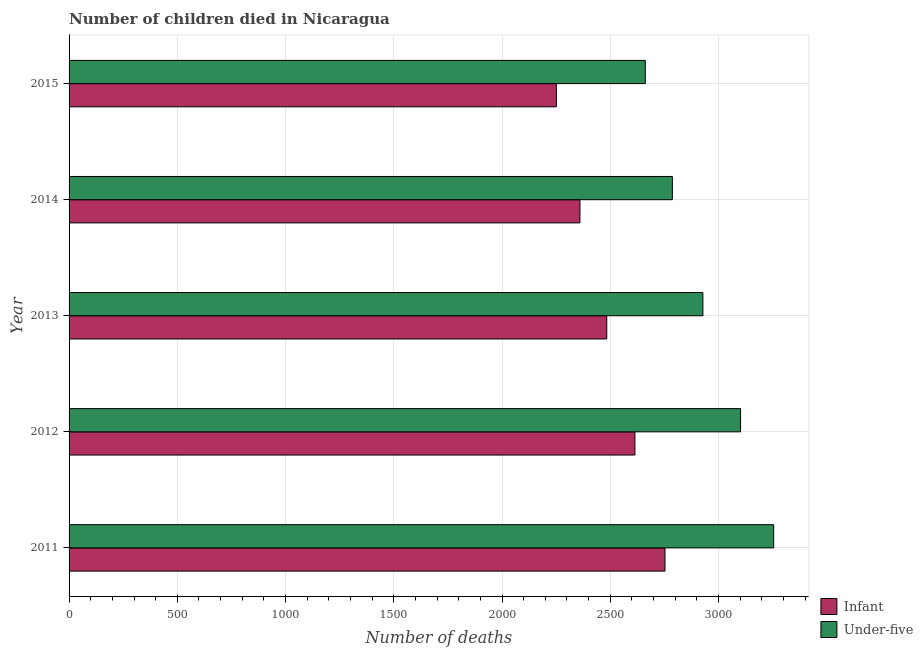How many different coloured bars are there?
Give a very brief answer. 2. How many groups of bars are there?
Ensure brevity in your answer.  5. What is the label of the 2nd group of bars from the top?
Provide a succinct answer. 2014. What is the number of infant deaths in 2015?
Make the answer very short. 2251. Across all years, what is the maximum number of under-five deaths?
Offer a very short reply. 3255. Across all years, what is the minimum number of under-five deaths?
Offer a very short reply. 2662. In which year was the number of infant deaths minimum?
Keep it short and to the point. 2015. What is the total number of under-five deaths in the graph?
Offer a terse response. 1.47e+04. What is the difference between the number of infant deaths in 2013 and that in 2014?
Your answer should be compact. 124. What is the difference between the number of infant deaths in 2014 and the number of under-five deaths in 2012?
Offer a very short reply. -742. What is the average number of under-five deaths per year?
Your response must be concise. 2946.8. In the year 2011, what is the difference between the number of under-five deaths and number of infant deaths?
Your answer should be very brief. 502. In how many years, is the number of infant deaths greater than 1100 ?
Offer a very short reply. 5. What is the ratio of the number of under-five deaths in 2013 to that in 2014?
Offer a terse response. 1.05. Is the difference between the number of infant deaths in 2013 and 2015 greater than the difference between the number of under-five deaths in 2013 and 2015?
Provide a succinct answer. No. What is the difference between the highest and the second highest number of under-five deaths?
Your answer should be compact. 153. What is the difference between the highest and the lowest number of infant deaths?
Offer a terse response. 502. In how many years, is the number of infant deaths greater than the average number of infant deaths taken over all years?
Offer a very short reply. 2. What does the 1st bar from the top in 2011 represents?
Provide a short and direct response. Under-five. What does the 2nd bar from the bottom in 2015 represents?
Give a very brief answer. Under-five. How many bars are there?
Make the answer very short. 10. Does the graph contain any zero values?
Provide a short and direct response. No. Does the graph contain grids?
Make the answer very short. Yes. How are the legend labels stacked?
Your answer should be very brief. Vertical. What is the title of the graph?
Your answer should be compact. Number of children died in Nicaragua. What is the label or title of the X-axis?
Make the answer very short. Number of deaths. What is the Number of deaths of Infant in 2011?
Ensure brevity in your answer.  2753. What is the Number of deaths of Under-five in 2011?
Your answer should be very brief. 3255. What is the Number of deaths in Infant in 2012?
Offer a very short reply. 2614. What is the Number of deaths in Under-five in 2012?
Your answer should be very brief. 3102. What is the Number of deaths of Infant in 2013?
Offer a terse response. 2484. What is the Number of deaths of Under-five in 2013?
Provide a succinct answer. 2928. What is the Number of deaths in Infant in 2014?
Your answer should be compact. 2360. What is the Number of deaths in Under-five in 2014?
Offer a very short reply. 2787. What is the Number of deaths in Infant in 2015?
Keep it short and to the point. 2251. What is the Number of deaths of Under-five in 2015?
Provide a short and direct response. 2662. Across all years, what is the maximum Number of deaths in Infant?
Your response must be concise. 2753. Across all years, what is the maximum Number of deaths in Under-five?
Your answer should be very brief. 3255. Across all years, what is the minimum Number of deaths of Infant?
Offer a very short reply. 2251. Across all years, what is the minimum Number of deaths of Under-five?
Your answer should be compact. 2662. What is the total Number of deaths of Infant in the graph?
Ensure brevity in your answer.  1.25e+04. What is the total Number of deaths of Under-five in the graph?
Your answer should be very brief. 1.47e+04. What is the difference between the Number of deaths in Infant in 2011 and that in 2012?
Provide a short and direct response. 139. What is the difference between the Number of deaths of Under-five in 2011 and that in 2012?
Make the answer very short. 153. What is the difference between the Number of deaths in Infant in 2011 and that in 2013?
Keep it short and to the point. 269. What is the difference between the Number of deaths in Under-five in 2011 and that in 2013?
Provide a succinct answer. 327. What is the difference between the Number of deaths of Infant in 2011 and that in 2014?
Provide a short and direct response. 393. What is the difference between the Number of deaths in Under-five in 2011 and that in 2014?
Offer a terse response. 468. What is the difference between the Number of deaths in Infant in 2011 and that in 2015?
Ensure brevity in your answer.  502. What is the difference between the Number of deaths of Under-five in 2011 and that in 2015?
Keep it short and to the point. 593. What is the difference between the Number of deaths of Infant in 2012 and that in 2013?
Your answer should be compact. 130. What is the difference between the Number of deaths of Under-five in 2012 and that in 2013?
Offer a very short reply. 174. What is the difference between the Number of deaths in Infant in 2012 and that in 2014?
Provide a succinct answer. 254. What is the difference between the Number of deaths in Under-five in 2012 and that in 2014?
Your response must be concise. 315. What is the difference between the Number of deaths in Infant in 2012 and that in 2015?
Your response must be concise. 363. What is the difference between the Number of deaths of Under-five in 2012 and that in 2015?
Ensure brevity in your answer.  440. What is the difference between the Number of deaths in Infant in 2013 and that in 2014?
Give a very brief answer. 124. What is the difference between the Number of deaths of Under-five in 2013 and that in 2014?
Keep it short and to the point. 141. What is the difference between the Number of deaths of Infant in 2013 and that in 2015?
Provide a succinct answer. 233. What is the difference between the Number of deaths in Under-five in 2013 and that in 2015?
Make the answer very short. 266. What is the difference between the Number of deaths of Infant in 2014 and that in 2015?
Offer a terse response. 109. What is the difference between the Number of deaths of Under-five in 2014 and that in 2015?
Keep it short and to the point. 125. What is the difference between the Number of deaths of Infant in 2011 and the Number of deaths of Under-five in 2012?
Offer a very short reply. -349. What is the difference between the Number of deaths of Infant in 2011 and the Number of deaths of Under-five in 2013?
Your answer should be very brief. -175. What is the difference between the Number of deaths in Infant in 2011 and the Number of deaths in Under-five in 2014?
Ensure brevity in your answer.  -34. What is the difference between the Number of deaths of Infant in 2011 and the Number of deaths of Under-five in 2015?
Offer a very short reply. 91. What is the difference between the Number of deaths of Infant in 2012 and the Number of deaths of Under-five in 2013?
Ensure brevity in your answer.  -314. What is the difference between the Number of deaths of Infant in 2012 and the Number of deaths of Under-five in 2014?
Offer a terse response. -173. What is the difference between the Number of deaths of Infant in 2012 and the Number of deaths of Under-five in 2015?
Offer a very short reply. -48. What is the difference between the Number of deaths in Infant in 2013 and the Number of deaths in Under-five in 2014?
Your response must be concise. -303. What is the difference between the Number of deaths of Infant in 2013 and the Number of deaths of Under-five in 2015?
Make the answer very short. -178. What is the difference between the Number of deaths in Infant in 2014 and the Number of deaths in Under-five in 2015?
Offer a very short reply. -302. What is the average Number of deaths of Infant per year?
Ensure brevity in your answer.  2492.4. What is the average Number of deaths of Under-five per year?
Your response must be concise. 2946.8. In the year 2011, what is the difference between the Number of deaths in Infant and Number of deaths in Under-five?
Keep it short and to the point. -502. In the year 2012, what is the difference between the Number of deaths in Infant and Number of deaths in Under-five?
Your response must be concise. -488. In the year 2013, what is the difference between the Number of deaths of Infant and Number of deaths of Under-five?
Your answer should be compact. -444. In the year 2014, what is the difference between the Number of deaths of Infant and Number of deaths of Under-five?
Your answer should be very brief. -427. In the year 2015, what is the difference between the Number of deaths in Infant and Number of deaths in Under-five?
Offer a terse response. -411. What is the ratio of the Number of deaths of Infant in 2011 to that in 2012?
Your answer should be compact. 1.05. What is the ratio of the Number of deaths of Under-five in 2011 to that in 2012?
Your response must be concise. 1.05. What is the ratio of the Number of deaths in Infant in 2011 to that in 2013?
Keep it short and to the point. 1.11. What is the ratio of the Number of deaths of Under-five in 2011 to that in 2013?
Offer a terse response. 1.11. What is the ratio of the Number of deaths of Infant in 2011 to that in 2014?
Provide a short and direct response. 1.17. What is the ratio of the Number of deaths in Under-five in 2011 to that in 2014?
Your answer should be very brief. 1.17. What is the ratio of the Number of deaths in Infant in 2011 to that in 2015?
Provide a succinct answer. 1.22. What is the ratio of the Number of deaths in Under-five in 2011 to that in 2015?
Provide a succinct answer. 1.22. What is the ratio of the Number of deaths in Infant in 2012 to that in 2013?
Make the answer very short. 1.05. What is the ratio of the Number of deaths of Under-five in 2012 to that in 2013?
Provide a short and direct response. 1.06. What is the ratio of the Number of deaths of Infant in 2012 to that in 2014?
Give a very brief answer. 1.11. What is the ratio of the Number of deaths of Under-five in 2012 to that in 2014?
Offer a very short reply. 1.11. What is the ratio of the Number of deaths in Infant in 2012 to that in 2015?
Keep it short and to the point. 1.16. What is the ratio of the Number of deaths of Under-five in 2012 to that in 2015?
Give a very brief answer. 1.17. What is the ratio of the Number of deaths of Infant in 2013 to that in 2014?
Provide a succinct answer. 1.05. What is the ratio of the Number of deaths of Under-five in 2013 to that in 2014?
Make the answer very short. 1.05. What is the ratio of the Number of deaths in Infant in 2013 to that in 2015?
Your response must be concise. 1.1. What is the ratio of the Number of deaths in Under-five in 2013 to that in 2015?
Your answer should be compact. 1.1. What is the ratio of the Number of deaths in Infant in 2014 to that in 2015?
Provide a succinct answer. 1.05. What is the ratio of the Number of deaths of Under-five in 2014 to that in 2015?
Provide a succinct answer. 1.05. What is the difference between the highest and the second highest Number of deaths in Infant?
Make the answer very short. 139. What is the difference between the highest and the second highest Number of deaths of Under-five?
Ensure brevity in your answer.  153. What is the difference between the highest and the lowest Number of deaths of Infant?
Provide a short and direct response. 502. What is the difference between the highest and the lowest Number of deaths of Under-five?
Your response must be concise. 593. 